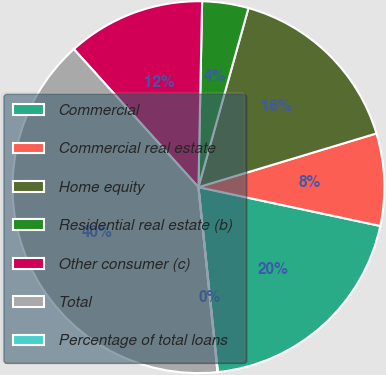Convert chart to OTSL. <chart><loc_0><loc_0><loc_500><loc_500><pie_chart><fcel>Commercial<fcel>Commercial real estate<fcel>Home equity<fcel>Residential real estate (b)<fcel>Other consumer (c)<fcel>Total<fcel>Percentage of total loans<nl><fcel>19.99%<fcel>8.01%<fcel>16.0%<fcel>4.02%<fcel>12.0%<fcel>39.95%<fcel>0.03%<nl></chart> 